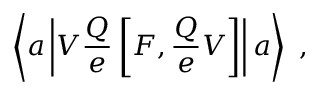Convert formula to latex. <formula><loc_0><loc_0><loc_500><loc_500>\left \langle a \left | V \frac { Q } { e } \left [ F , \frac { Q } { e } V \right ] \right | a \right \rangle ,</formula> 